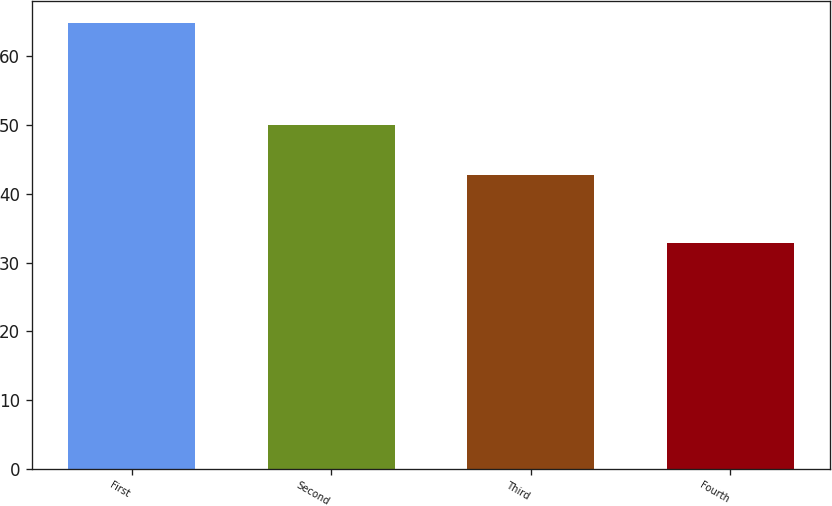Convert chart to OTSL. <chart><loc_0><loc_0><loc_500><loc_500><bar_chart><fcel>First<fcel>Second<fcel>Third<fcel>Fourth<nl><fcel>64.85<fcel>50<fcel>42.75<fcel>32.83<nl></chart> 